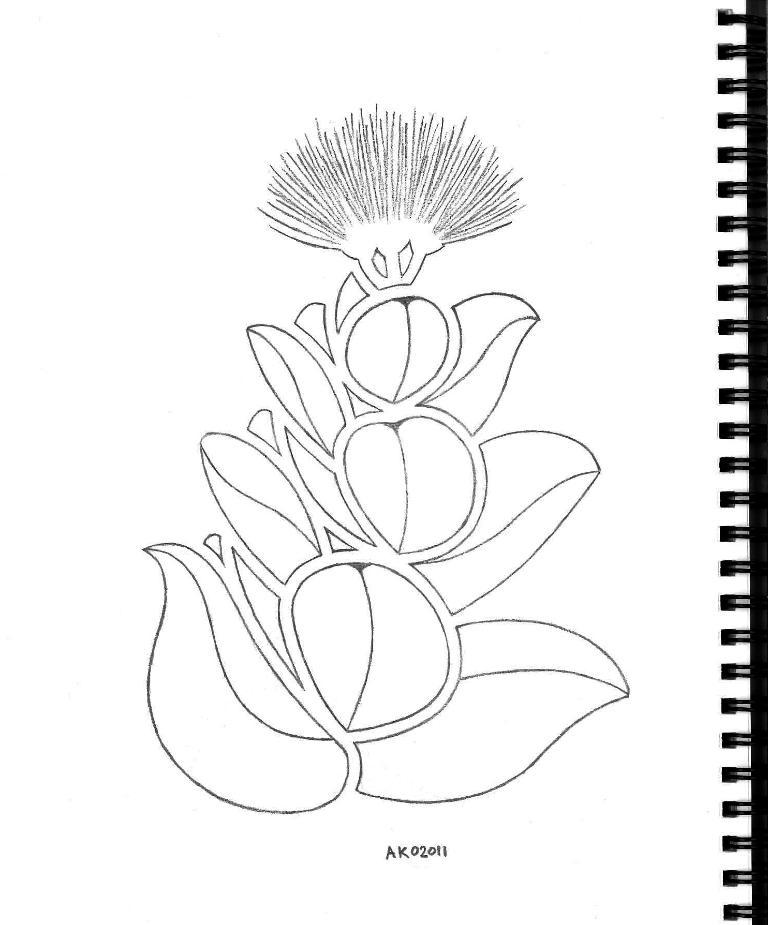What medium is used to create the image? The image is a pencil art on paper. What can be seen within the art? There are letters in the art. How is the paper bound? The paper has a spiral binding with plastic coils. What type of heart is depicted in the pencil art? There is no heart depicted in the pencil art; it features letters instead. 